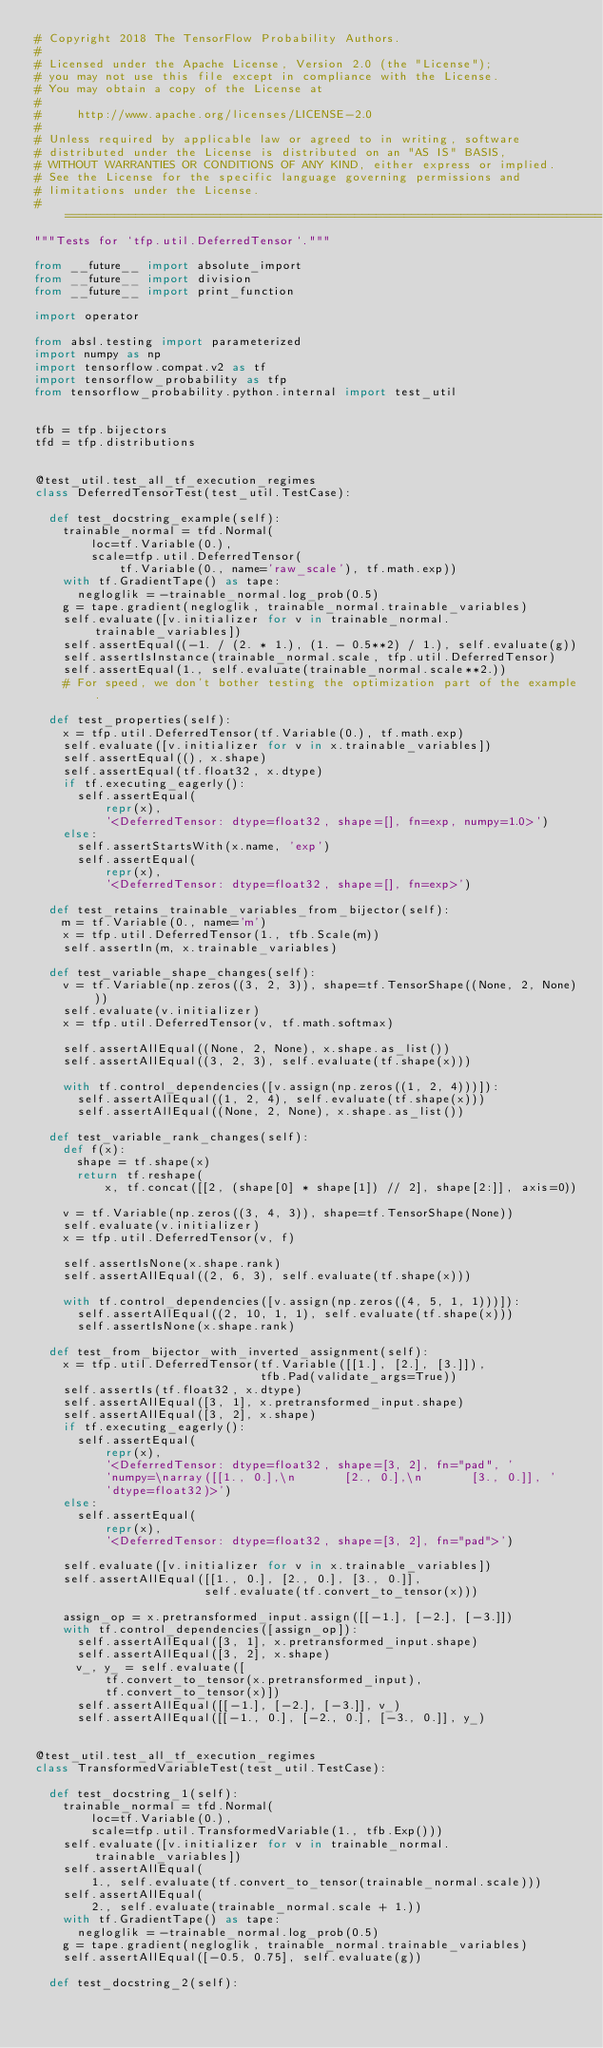<code> <loc_0><loc_0><loc_500><loc_500><_Python_># Copyright 2018 The TensorFlow Probability Authors.
#
# Licensed under the Apache License, Version 2.0 (the "License");
# you may not use this file except in compliance with the License.
# You may obtain a copy of the License at
#
#     http://www.apache.org/licenses/LICENSE-2.0
#
# Unless required by applicable law or agreed to in writing, software
# distributed under the License is distributed on an "AS IS" BASIS,
# WITHOUT WARRANTIES OR CONDITIONS OF ANY KIND, either express or implied.
# See the License for the specific language governing permissions and
# limitations under the License.
# ============================================================================
"""Tests for `tfp.util.DeferredTensor`."""

from __future__ import absolute_import
from __future__ import division
from __future__ import print_function

import operator

from absl.testing import parameterized
import numpy as np
import tensorflow.compat.v2 as tf
import tensorflow_probability as tfp
from tensorflow_probability.python.internal import test_util


tfb = tfp.bijectors
tfd = tfp.distributions


@test_util.test_all_tf_execution_regimes
class DeferredTensorTest(test_util.TestCase):

  def test_docstring_example(self):
    trainable_normal = tfd.Normal(
        loc=tf.Variable(0.),
        scale=tfp.util.DeferredTensor(
            tf.Variable(0., name='raw_scale'), tf.math.exp))
    with tf.GradientTape() as tape:
      negloglik = -trainable_normal.log_prob(0.5)
    g = tape.gradient(negloglik, trainable_normal.trainable_variables)
    self.evaluate([v.initializer for v in trainable_normal.trainable_variables])
    self.assertEqual((-1. / (2. * 1.), (1. - 0.5**2) / 1.), self.evaluate(g))
    self.assertIsInstance(trainable_normal.scale, tfp.util.DeferredTensor)
    self.assertEqual(1., self.evaluate(trainable_normal.scale**2.))
    # For speed, we don't bother testing the optimization part of the example.

  def test_properties(self):
    x = tfp.util.DeferredTensor(tf.Variable(0.), tf.math.exp)
    self.evaluate([v.initializer for v in x.trainable_variables])
    self.assertEqual((), x.shape)
    self.assertEqual(tf.float32, x.dtype)
    if tf.executing_eagerly():
      self.assertEqual(
          repr(x),
          '<DeferredTensor: dtype=float32, shape=[], fn=exp, numpy=1.0>')
    else:
      self.assertStartsWith(x.name, 'exp')
      self.assertEqual(
          repr(x),
          '<DeferredTensor: dtype=float32, shape=[], fn=exp>')

  def test_retains_trainable_variables_from_bijector(self):
    m = tf.Variable(0., name='m')
    x = tfp.util.DeferredTensor(1., tfb.Scale(m))
    self.assertIn(m, x.trainable_variables)

  def test_variable_shape_changes(self):
    v = tf.Variable(np.zeros((3, 2, 3)), shape=tf.TensorShape((None, 2, None)))
    self.evaluate(v.initializer)
    x = tfp.util.DeferredTensor(v, tf.math.softmax)

    self.assertAllEqual((None, 2, None), x.shape.as_list())
    self.assertAllEqual((3, 2, 3), self.evaluate(tf.shape(x)))

    with tf.control_dependencies([v.assign(np.zeros((1, 2, 4)))]):
      self.assertAllEqual((1, 2, 4), self.evaluate(tf.shape(x)))
      self.assertAllEqual((None, 2, None), x.shape.as_list())

  def test_variable_rank_changes(self):
    def f(x):
      shape = tf.shape(x)
      return tf.reshape(
          x, tf.concat([[2, (shape[0] * shape[1]) // 2], shape[2:]], axis=0))

    v = tf.Variable(np.zeros((3, 4, 3)), shape=tf.TensorShape(None))
    self.evaluate(v.initializer)
    x = tfp.util.DeferredTensor(v, f)

    self.assertIsNone(x.shape.rank)
    self.assertAllEqual((2, 6, 3), self.evaluate(tf.shape(x)))

    with tf.control_dependencies([v.assign(np.zeros((4, 5, 1, 1)))]):
      self.assertAllEqual((2, 10, 1, 1), self.evaluate(tf.shape(x)))
      self.assertIsNone(x.shape.rank)

  def test_from_bijector_with_inverted_assignment(self):
    x = tfp.util.DeferredTensor(tf.Variable([[1.], [2.], [3.]]),
                                tfb.Pad(validate_args=True))
    self.assertIs(tf.float32, x.dtype)
    self.assertAllEqual([3, 1], x.pretransformed_input.shape)
    self.assertAllEqual([3, 2], x.shape)
    if tf.executing_eagerly():
      self.assertEqual(
          repr(x),
          '<DeferredTensor: dtype=float32, shape=[3, 2], fn="pad", '
          'numpy=\narray([[1., 0.],\n       [2., 0.],\n       [3., 0.]], '
          'dtype=float32)>')
    else:
      self.assertEqual(
          repr(x),
          '<DeferredTensor: dtype=float32, shape=[3, 2], fn="pad">')

    self.evaluate([v.initializer for v in x.trainable_variables])
    self.assertAllEqual([[1., 0.], [2., 0.], [3., 0.]],
                        self.evaluate(tf.convert_to_tensor(x)))

    assign_op = x.pretransformed_input.assign([[-1.], [-2.], [-3.]])
    with tf.control_dependencies([assign_op]):
      self.assertAllEqual([3, 1], x.pretransformed_input.shape)
      self.assertAllEqual([3, 2], x.shape)
      v_, y_ = self.evaluate([
          tf.convert_to_tensor(x.pretransformed_input),
          tf.convert_to_tensor(x)])
      self.assertAllEqual([[-1.], [-2.], [-3.]], v_)
      self.assertAllEqual([[-1., 0.], [-2., 0.], [-3., 0.]], y_)


@test_util.test_all_tf_execution_regimes
class TransformedVariableTest(test_util.TestCase):

  def test_docstring_1(self):
    trainable_normal = tfd.Normal(
        loc=tf.Variable(0.),
        scale=tfp.util.TransformedVariable(1., tfb.Exp()))
    self.evaluate([v.initializer for v in trainable_normal.trainable_variables])
    self.assertAllEqual(
        1., self.evaluate(tf.convert_to_tensor(trainable_normal.scale)))
    self.assertAllEqual(
        2., self.evaluate(trainable_normal.scale + 1.))
    with tf.GradientTape() as tape:
      negloglik = -trainable_normal.log_prob(0.5)
    g = tape.gradient(negloglik, trainable_normal.trainable_variables)
    self.assertAllEqual([-0.5, 0.75], self.evaluate(g))

  def test_docstring_2(self):</code> 